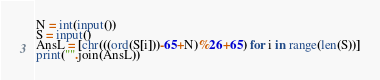Convert code to text. <code><loc_0><loc_0><loc_500><loc_500><_Python_>N = int(input())
S = input()
AnsL = [chr(((ord(S[i]))-65+N)%26+65) for i in range(len(S))]
print("".join(AnsL))</code> 